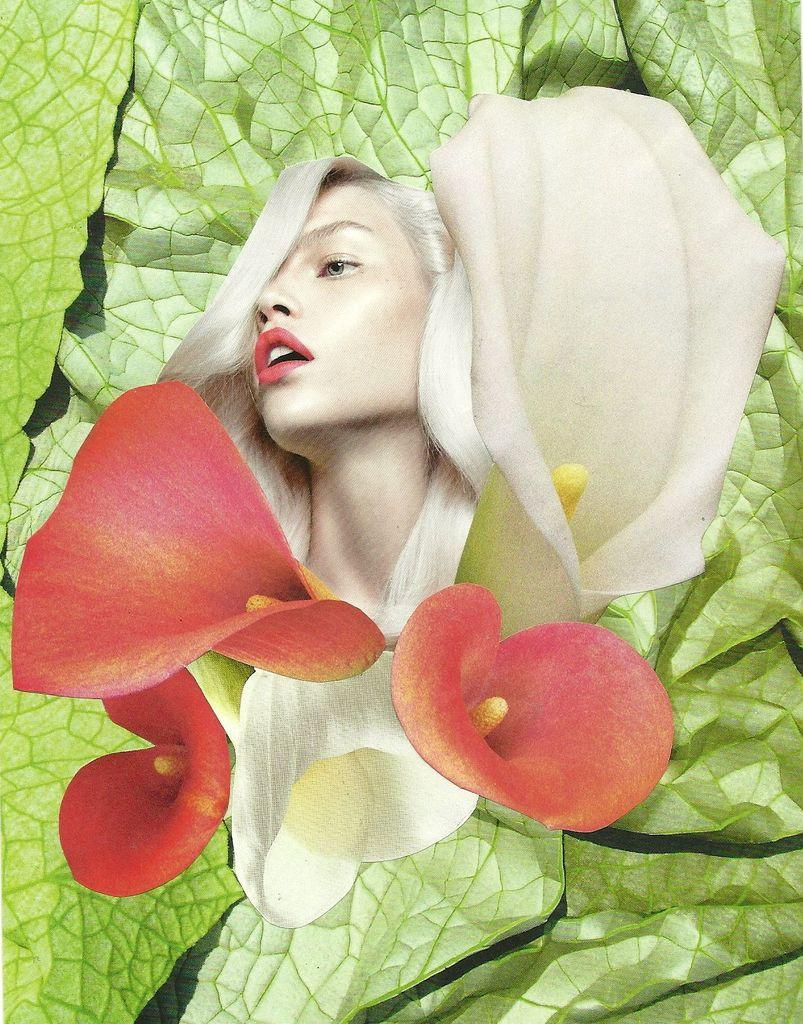What is the main subject of the image? There is a woman's face in the image. What other elements are present in the image besides the woman's face? There are flowers in the image. Can you describe the flowers in the image? The flowers are white and red in color. What color is the background of the image? The background of the image is green. Does the woman's face show any signs of pain in the image? There is no indication of pain on the woman's face in the image. Is there a tank visible in the image? There is no tank present in the image. 